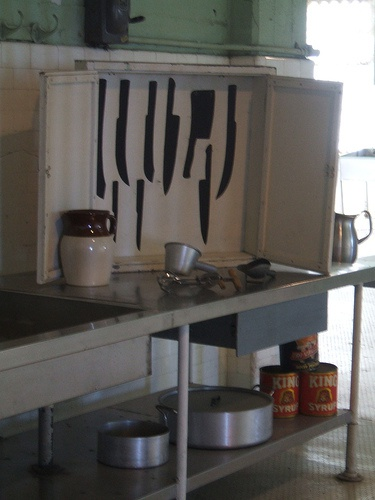Describe the objects in this image and their specific colors. I can see sink in black and darkgreen tones, bowl in darkgreen, black, and gray tones, knife in darkgreen, black, and gray tones, knife in darkgreen, black, and gray tones, and cup in darkgreen, gray, and black tones in this image. 